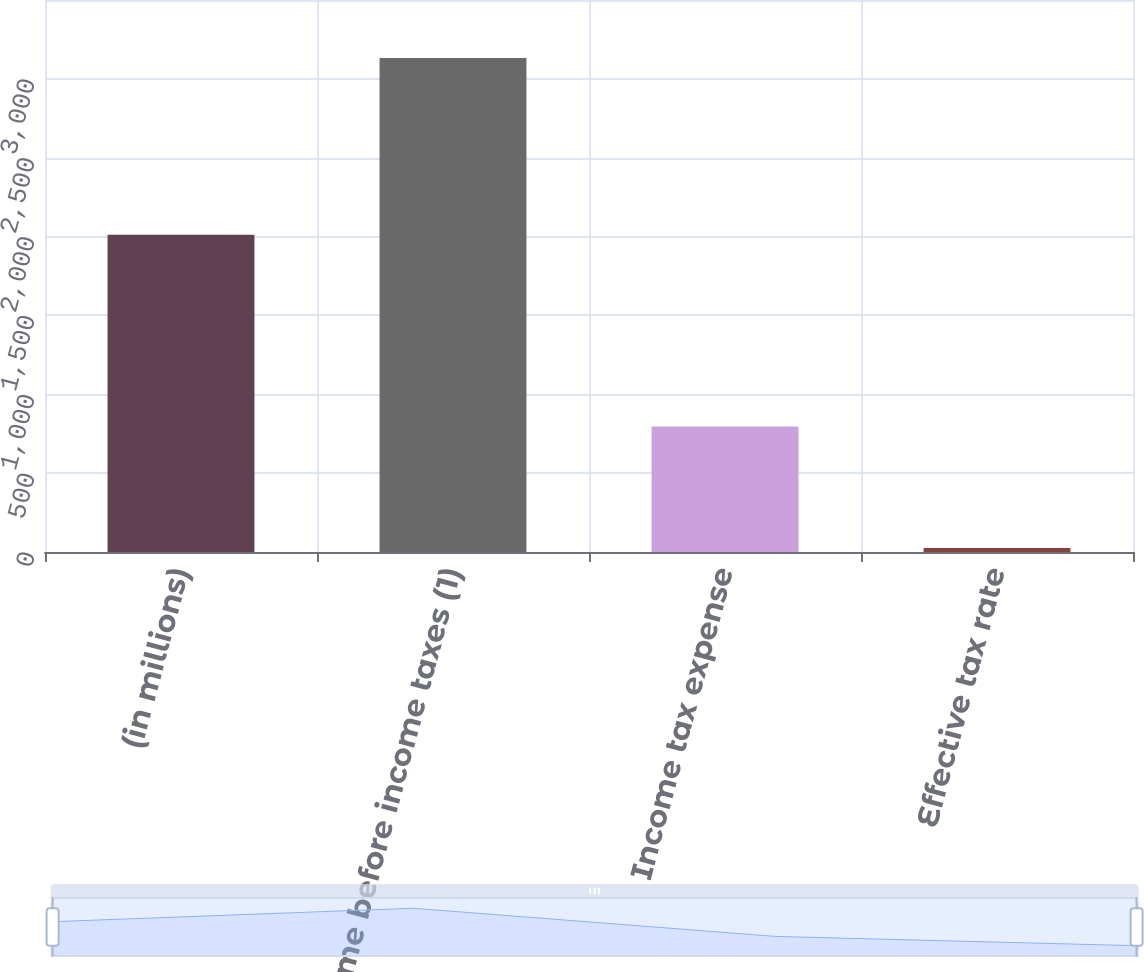Convert chart. <chart><loc_0><loc_0><loc_500><loc_500><bar_chart><fcel>(in millions)<fcel>Income before income taxes (1)<fcel>Income tax expense<fcel>Effective tax rate<nl><fcel>2011<fcel>3133<fcel>796<fcel>25.4<nl></chart> 